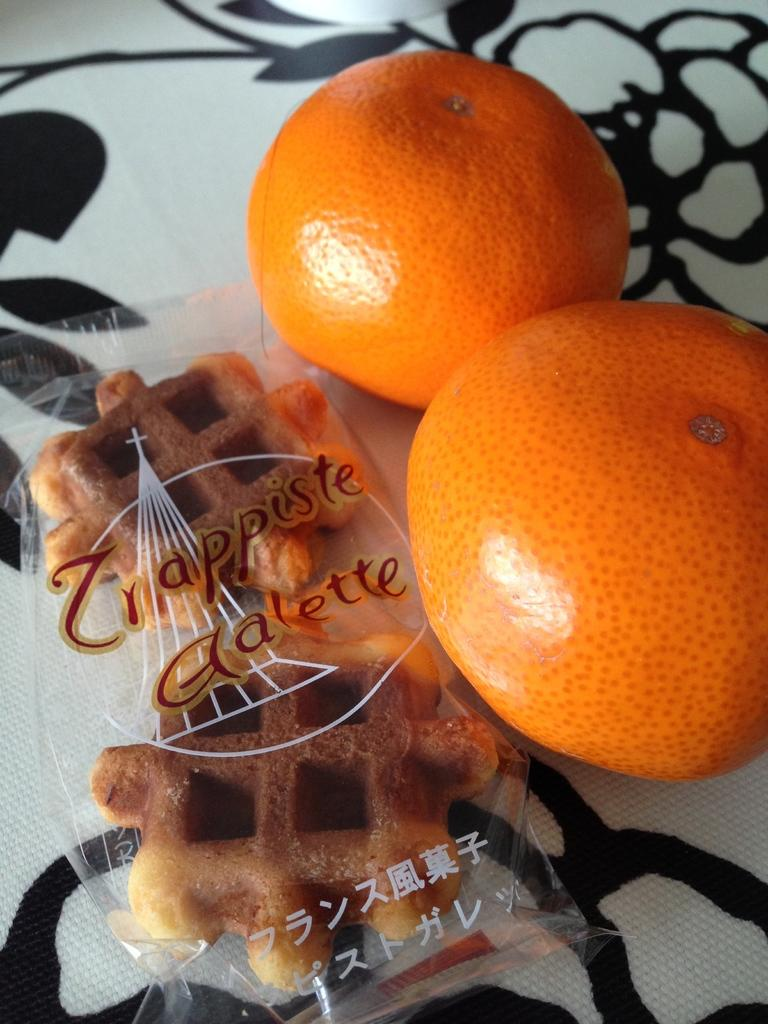What is the main subject of the image? The main subject of the image is food. Where is the food located in the image? The food is in the center of the image. What type of game is being played during the rainstorm in the image? There is no game or rainstorm present in the image; it only features food in the center. 